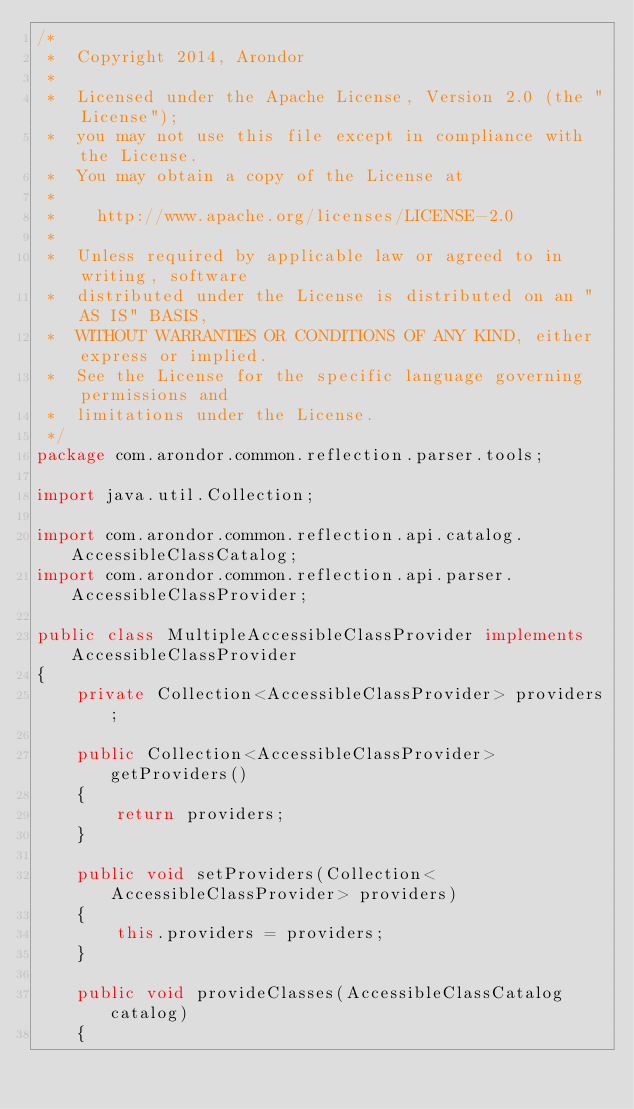<code> <loc_0><loc_0><loc_500><loc_500><_Java_>/*
 *  Copyright 2014, Arondor
 *
 *  Licensed under the Apache License, Version 2.0 (the "License");
 *  you may not use this file except in compliance with the License.
 *  You may obtain a copy of the License at
 *
 *    http://www.apache.org/licenses/LICENSE-2.0
 *
 *  Unless required by applicable law or agreed to in writing, software
 *  distributed under the License is distributed on an "AS IS" BASIS,
 *  WITHOUT WARRANTIES OR CONDITIONS OF ANY KIND, either express or implied.
 *  See the License for the specific language governing permissions and
 *  limitations under the License.
 */
package com.arondor.common.reflection.parser.tools;

import java.util.Collection;

import com.arondor.common.reflection.api.catalog.AccessibleClassCatalog;
import com.arondor.common.reflection.api.parser.AccessibleClassProvider;

public class MultipleAccessibleClassProvider implements AccessibleClassProvider
{
    private Collection<AccessibleClassProvider> providers;

    public Collection<AccessibleClassProvider> getProviders()
    {
        return providers;
    }

    public void setProviders(Collection<AccessibleClassProvider> providers)
    {
        this.providers = providers;
    }

    public void provideClasses(AccessibleClassCatalog catalog)
    {</code> 